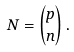Convert formula to latex. <formula><loc_0><loc_0><loc_500><loc_500>N = \binom { p } { n } \, .</formula> 